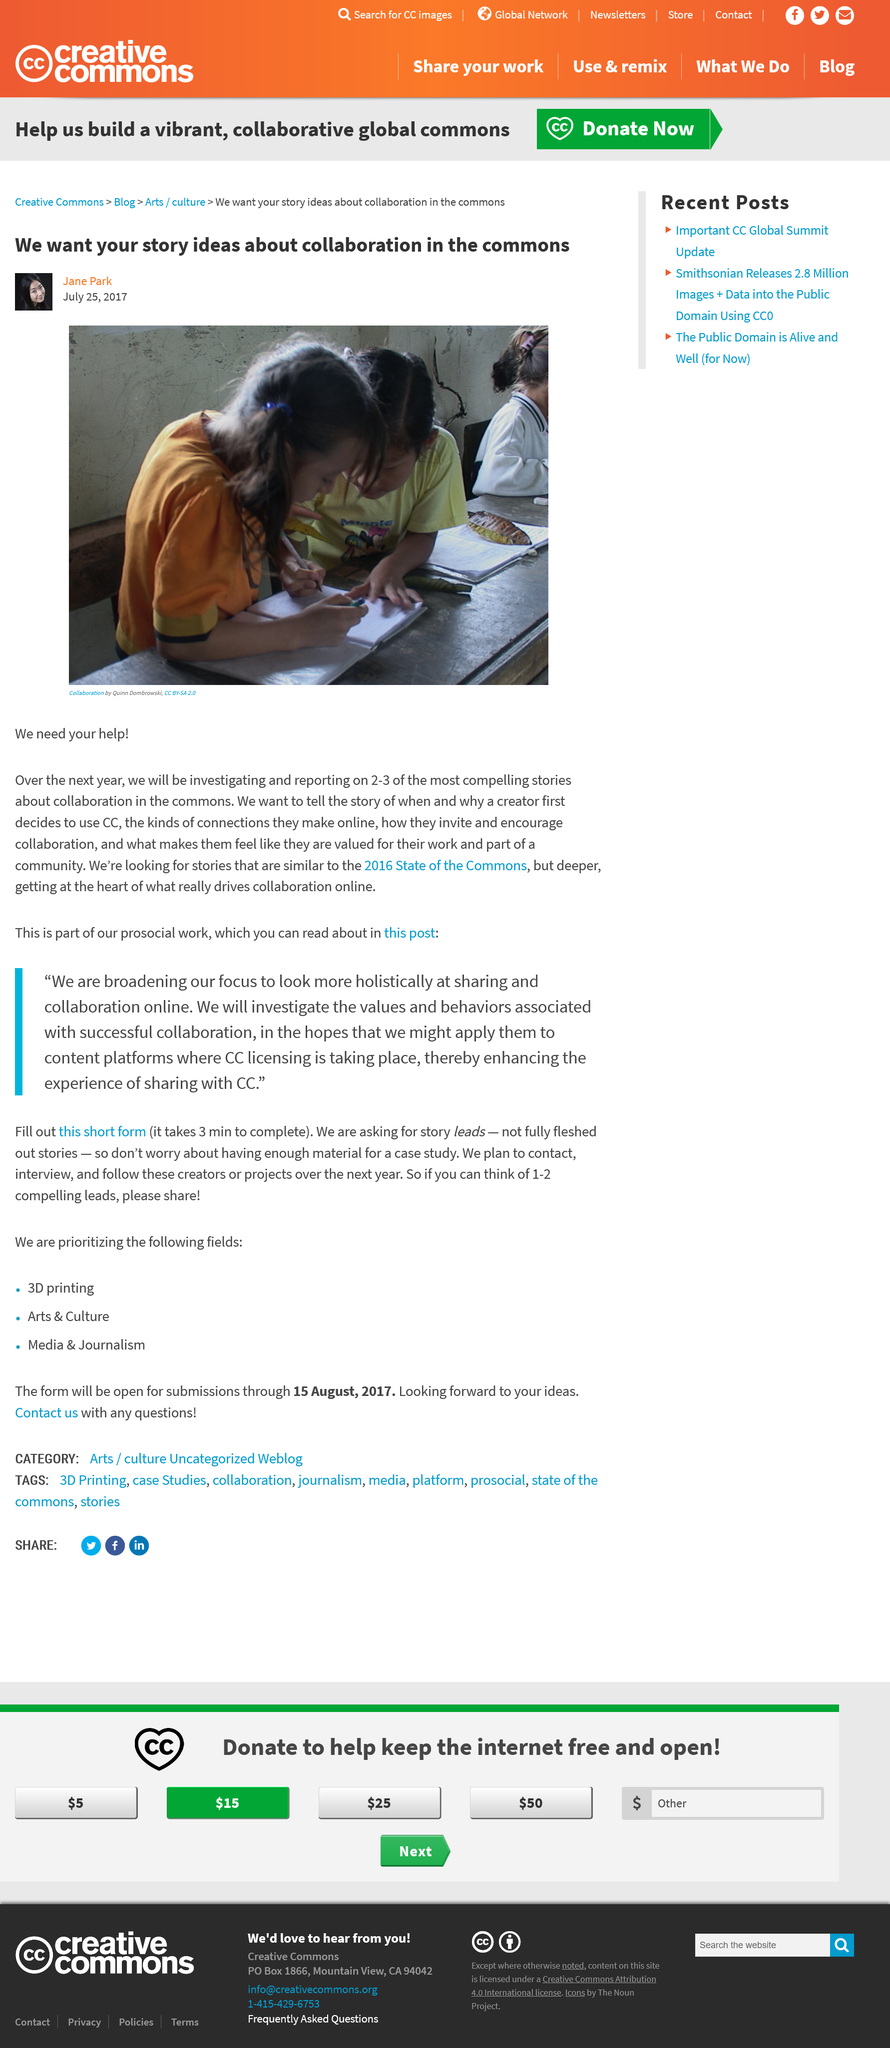Identify some key points in this picture. There is a call for stories that are similar to those in the 2016 State of the Commons report. Quinn Dombrowski took the photograph titled "Collaboration. Jane Park is reporting on the subject of collaboration in the commons. 